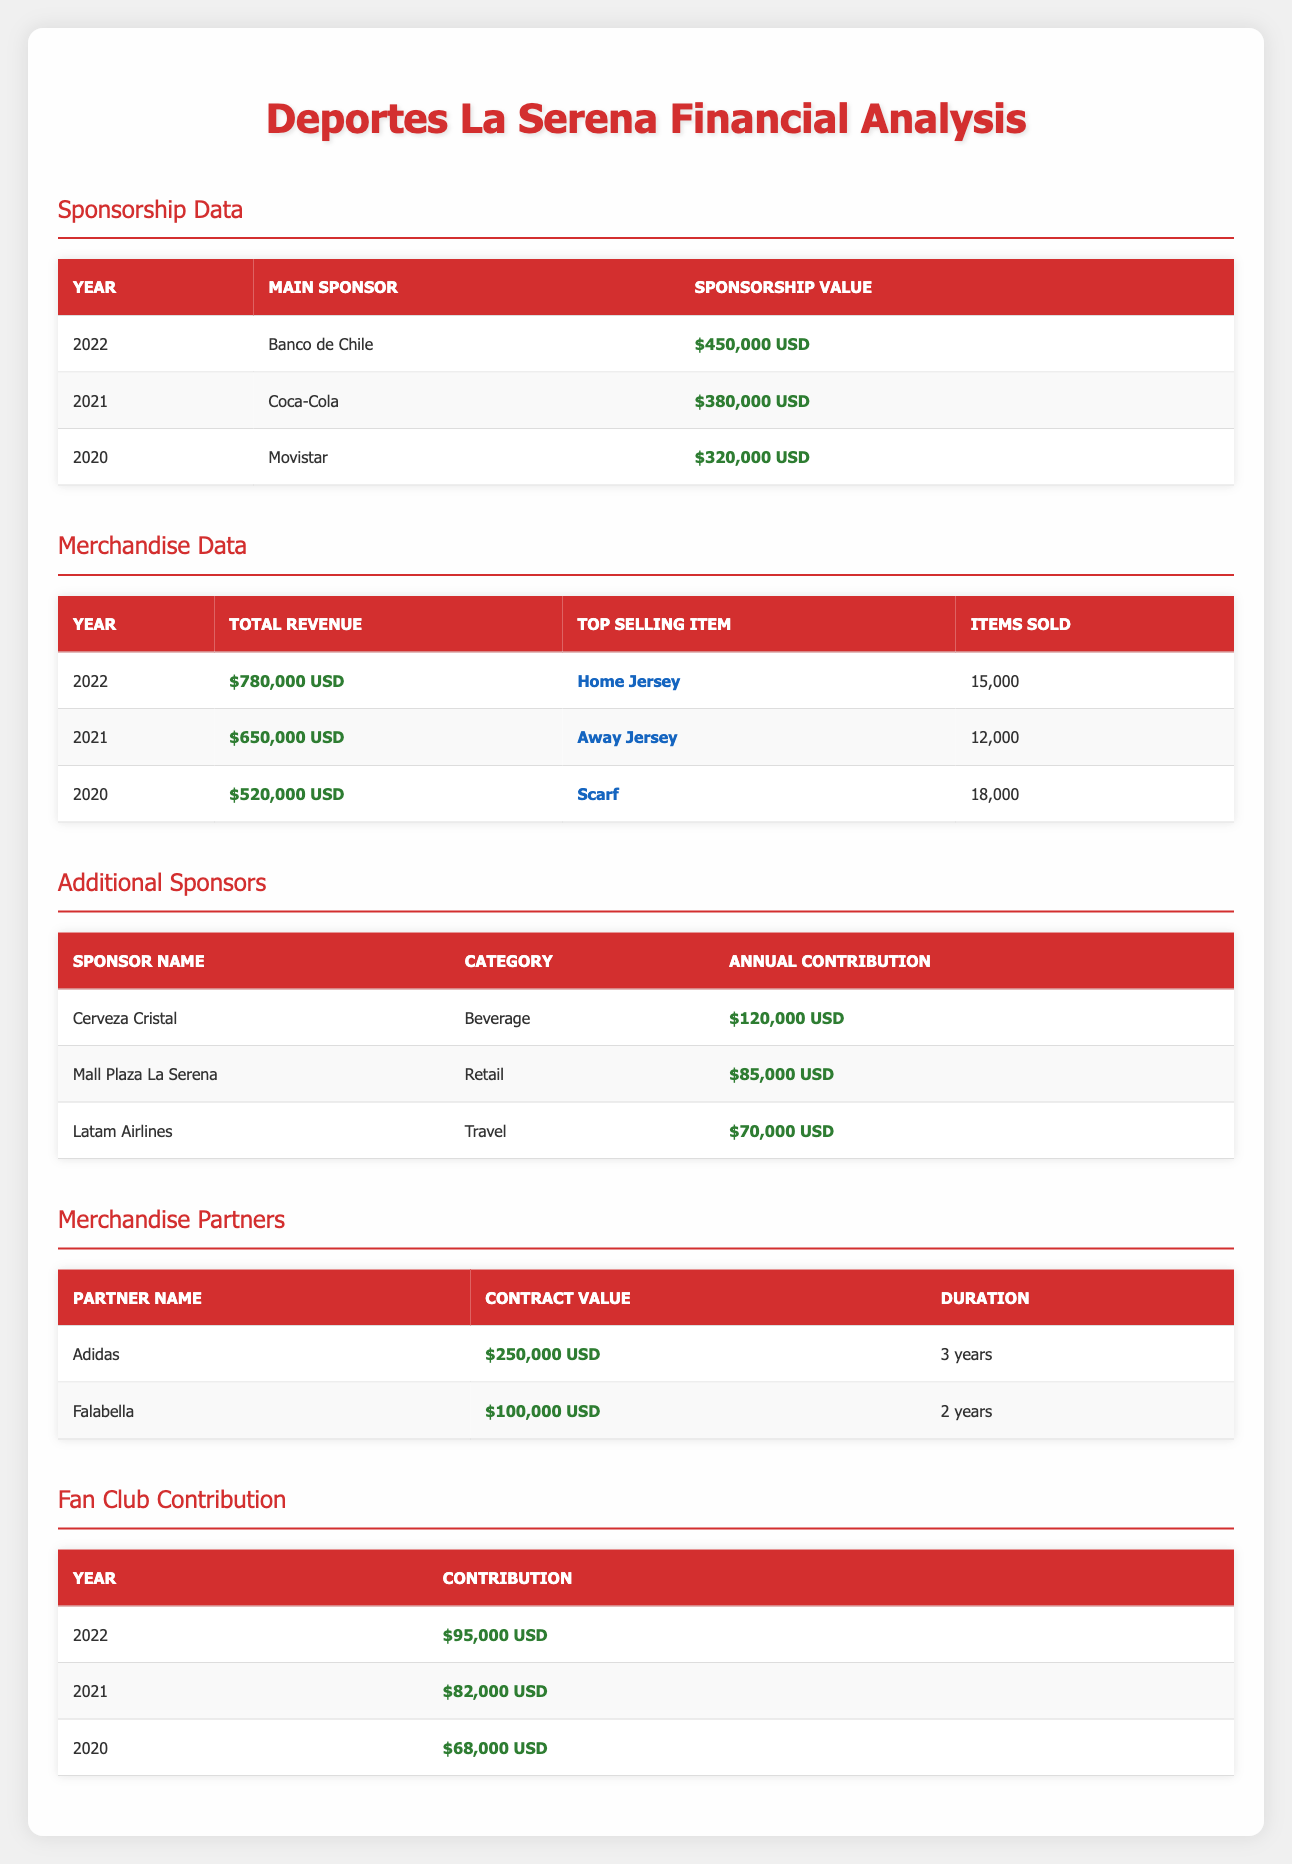What was the sponsorship value for Deportes La Serena in 2022? The table shows that the sponsorship value for 2022 is listed as $450,000 USD.
Answer: $450,000 USD Which item sold the most in merchandise in 2021? According to the merchandise data, the top selling item in 2021 was the Away Jersey.
Answer: Away Jersey What was the total revenue from merchandise in 2020? The merchandise data indicates that the total revenue for 2020 was $520,000 USD.
Answer: $520,000 USD What is the combined annual contribution from Cerveza Cristal and Mall Plaza La Serena? To find the combined contribution, add $120,000 USD (Cerveza Cristal) and $85,000 USD (Mall Plaza La Serena): $120,000 + $85,000 = $205,000 USD.
Answer: $205,000 USD Did Deportes La Serena have a higher sponsorship value in 2021 compared to 2020? The sponsorship value for 2021 was $380,000 USD, while in 2020 it was $320,000 USD. This shows that 2021's value was indeed higher.
Answer: Yes What was the percentage increase in total merchandise revenue from 2020 to 2022? The total revenue in 2020 was $520,000 USD and in 2022 it was $780,000 USD. The increase is $780,000 - $520,000 = $260,000 USD. To find the percentage increase: ($260,000 / $520,000) * 100 = 50%.
Answer: 50% Which sponsor had the lowest annual contribution? Looking at the additional sponsors, Latam Airlines has the lowest annual contribution of $70,000 USD.
Answer: Latam Airlines How many items were sold in total for merchandise across all three years? To find the total items sold, add the items sold each year: 15,000 (2022) + 12,000 (2021) + 18,000 (2020) = 45,000 items.
Answer: 45,000 items Was the total fan club contribution in 2021 greater than that in 2020? The fan club contribution for 2021 was $82,000 USD, and for 2020 it was $68,000 USD. Since $82,000 is greater than $68,000, the statement is true.
Answer: Yes 